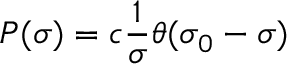<formula> <loc_0><loc_0><loc_500><loc_500>P ( \sigma ) = c { \frac { 1 } { \sigma } } \theta ( \sigma _ { 0 } - \sigma )</formula> 